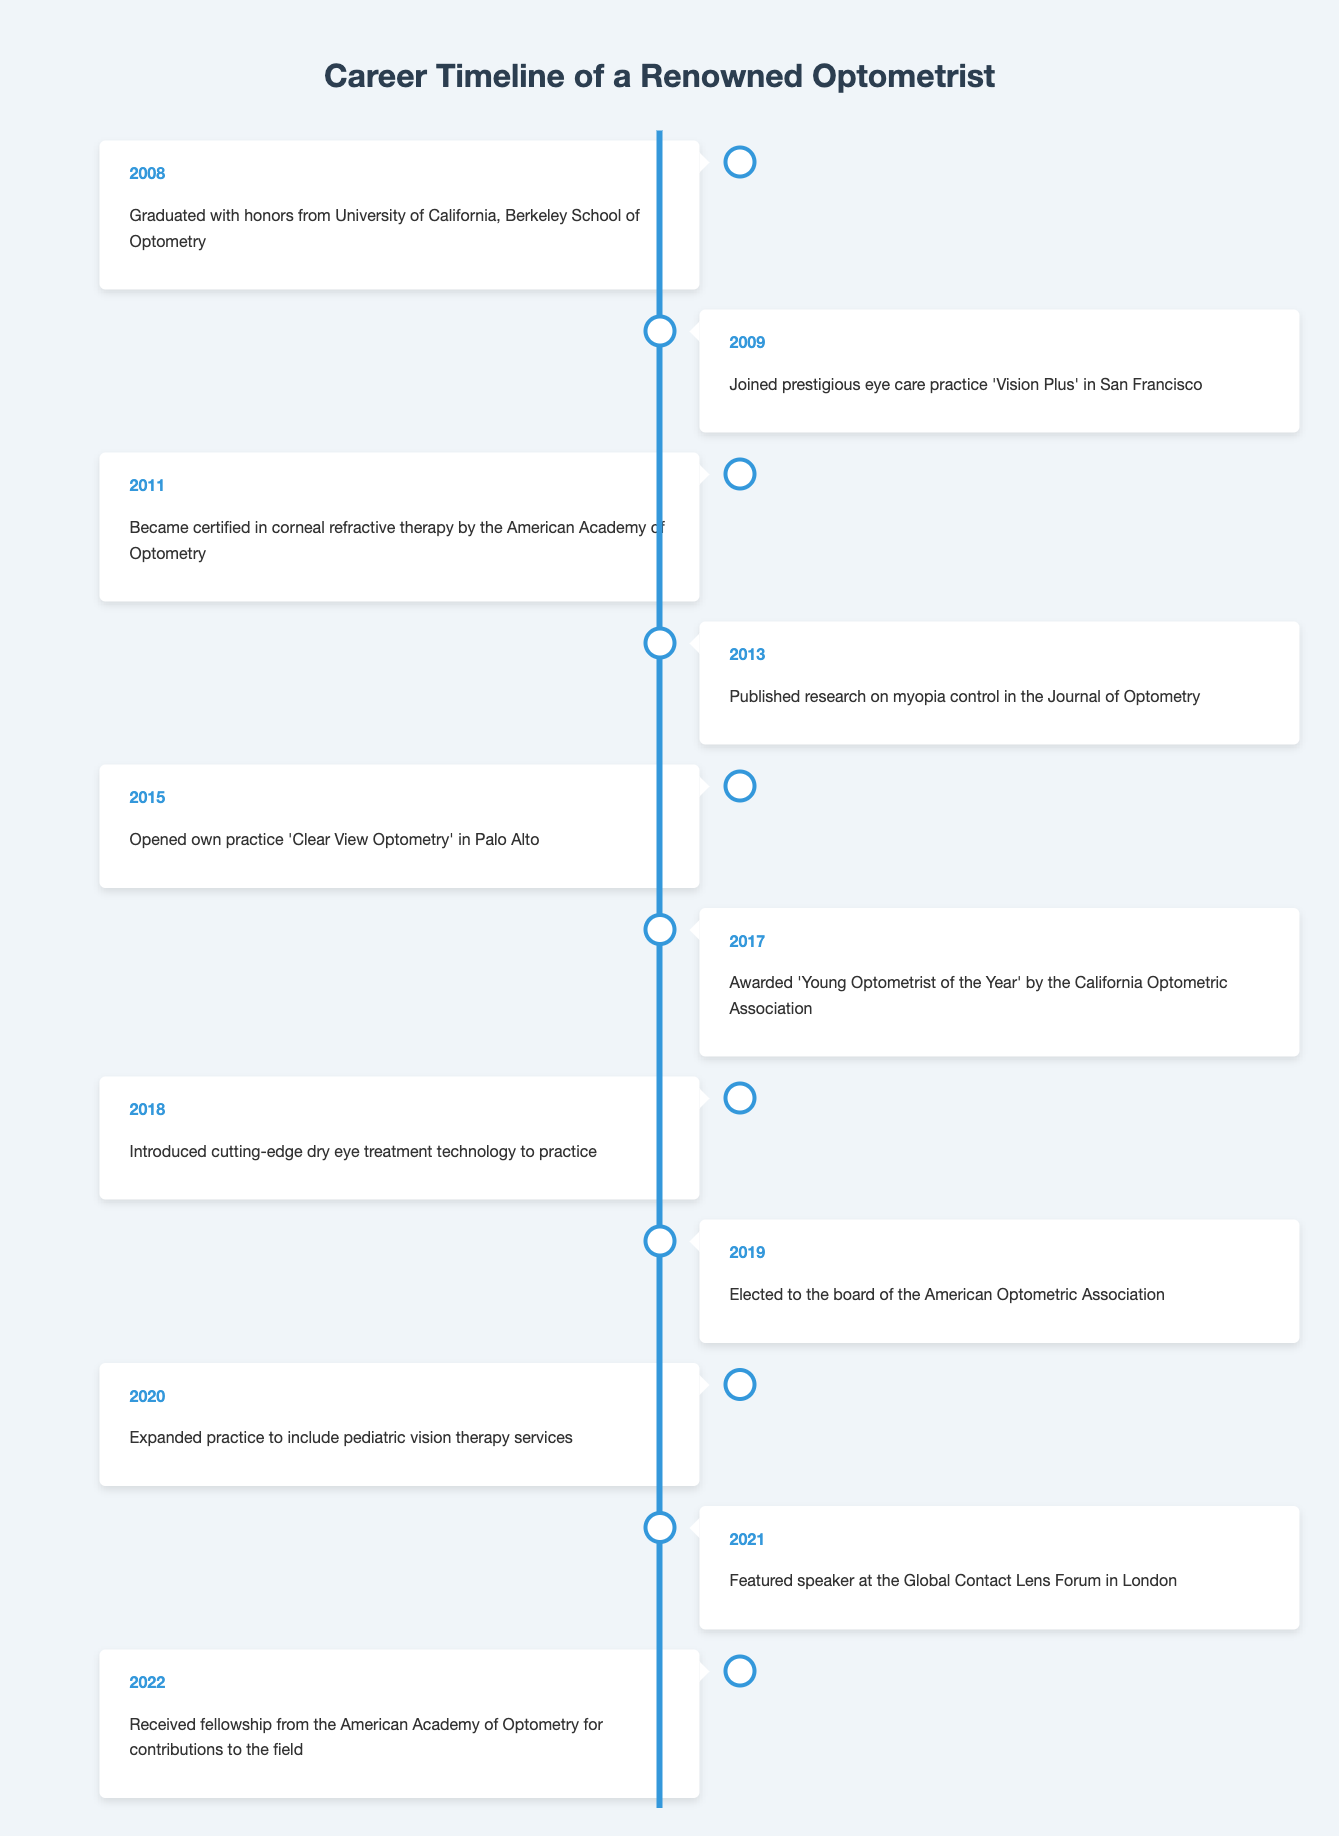What year did the optometrist graduate? The table states that the optometrist graduated in 2008 from the University of California, Berkeley School of Optometry.
Answer: 2008 What milestone occurred in 2015? According to the table, in 2015, the optometrist opened their own practice named 'Clear View Optometry' in Palo Alto.
Answer: Opened own practice 'Clear View Optometry' in Palo Alto How many years after graduation did the optometrist publish research? The optometrist graduated in 2008 and published research in 2013. Therefore, it took 2013 - 2008 = 5 years after graduation to publish the research.
Answer: 5 years Did the optometrist introduce new technology in 2018? Yes, the table confirms that in 2018, the optometrist introduced cutting-edge dry eye treatment technology to their practice.
Answer: Yes In which year was the optometrist recognized as 'Young Optometrist of the Year'? The timeline indicates that the optometrist was awarded 'Young Optometrist of the Year' in 2017.
Answer: 2017 What is the total number of significant milestones listed in the timeline? By counting the events listed from 2008 to 2022, we can see there are 11 significant milestones provided in the timeline.
Answer: 11 In what year did the optometrist join 'Vision Plus' in San Francisco? Referring to the table, the optometrist joined 'Vision Plus' in San Francisco in 2009, one year after graduation.
Answer: 2009 What percentage of the timeline events resulted in awards or recognitions? There are 2 milestones involving awards or recognitions (2017 and 2022) out of 11 total events. To find the percentage: (2 / 11) * 100 = approximately 18.18%.
Answer: 18.18% What major expansion occurred in 2020? The table notes that in 2020, the optometrist expanded their practice to include pediatric vision therapy services.
Answer: Expanded practice to include pediatric vision therapy services Did the optometrist participate as a speaker in any event before 2021? No, the first recorded speaking engagement was in 2021 at the Global Contact Lens Forum, as shown in the table.
Answer: No 